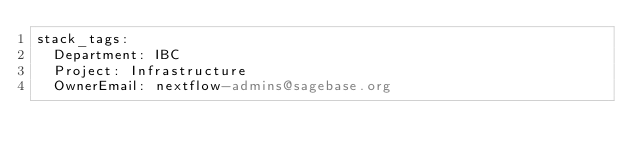Convert code to text. <code><loc_0><loc_0><loc_500><loc_500><_YAML_>stack_tags:
  Department: IBC
  Project: Infrastructure
  OwnerEmail: nextflow-admins@sagebase.org
</code> 